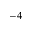Convert formula to latex. <formula><loc_0><loc_0><loc_500><loc_500>^ { - 4 }</formula> 